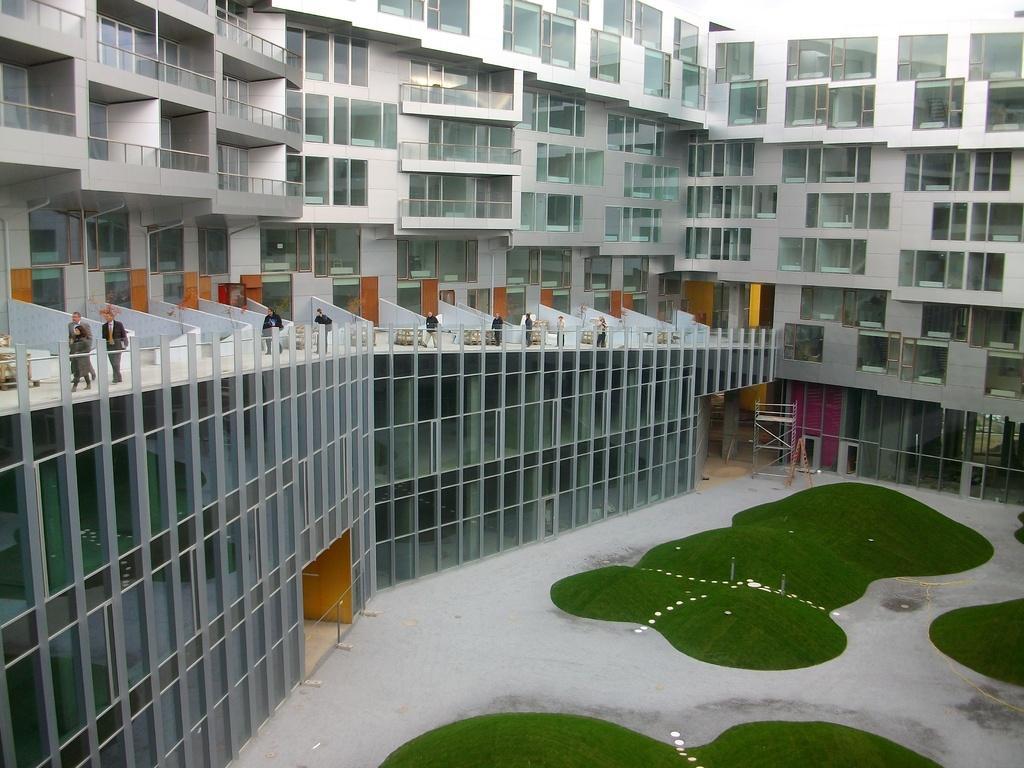In one or two sentences, can you explain what this image depicts? This is a building, where people are walking, this is grass. 